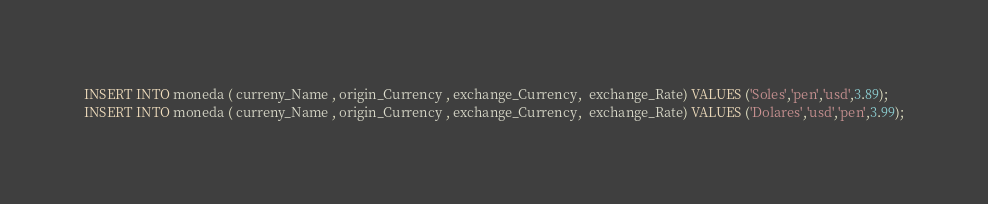Convert code to text. <code><loc_0><loc_0><loc_500><loc_500><_SQL_>INSERT INTO moneda ( curreny_Name , origin_Currency , exchange_Currency,  exchange_Rate) VALUES ('Soles','pen','usd',3.89);
INSERT INTO moneda ( curreny_Name , origin_Currency , exchange_Currency,  exchange_Rate) VALUES ('Dolares','usd','pen',3.99);</code> 